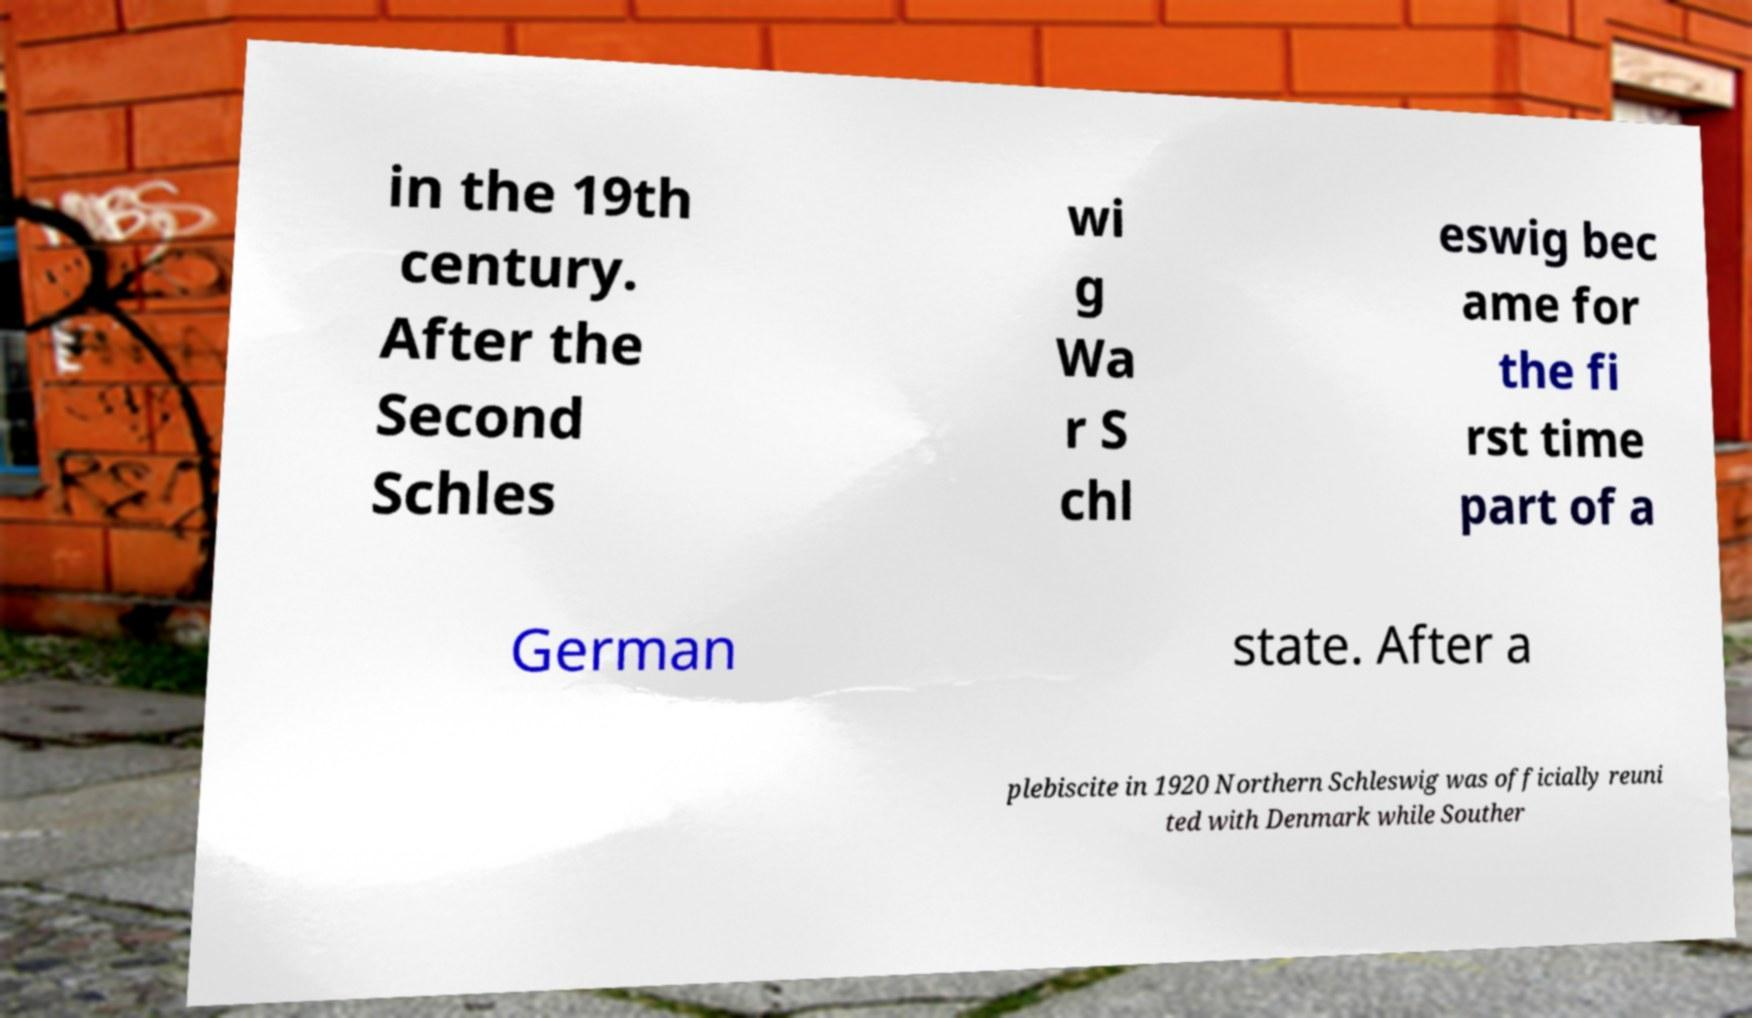Can you read and provide the text displayed in the image?This photo seems to have some interesting text. Can you extract and type it out for me? in the 19th century. After the Second Schles wi g Wa r S chl eswig bec ame for the fi rst time part of a German state. After a plebiscite in 1920 Northern Schleswig was officially reuni ted with Denmark while Souther 